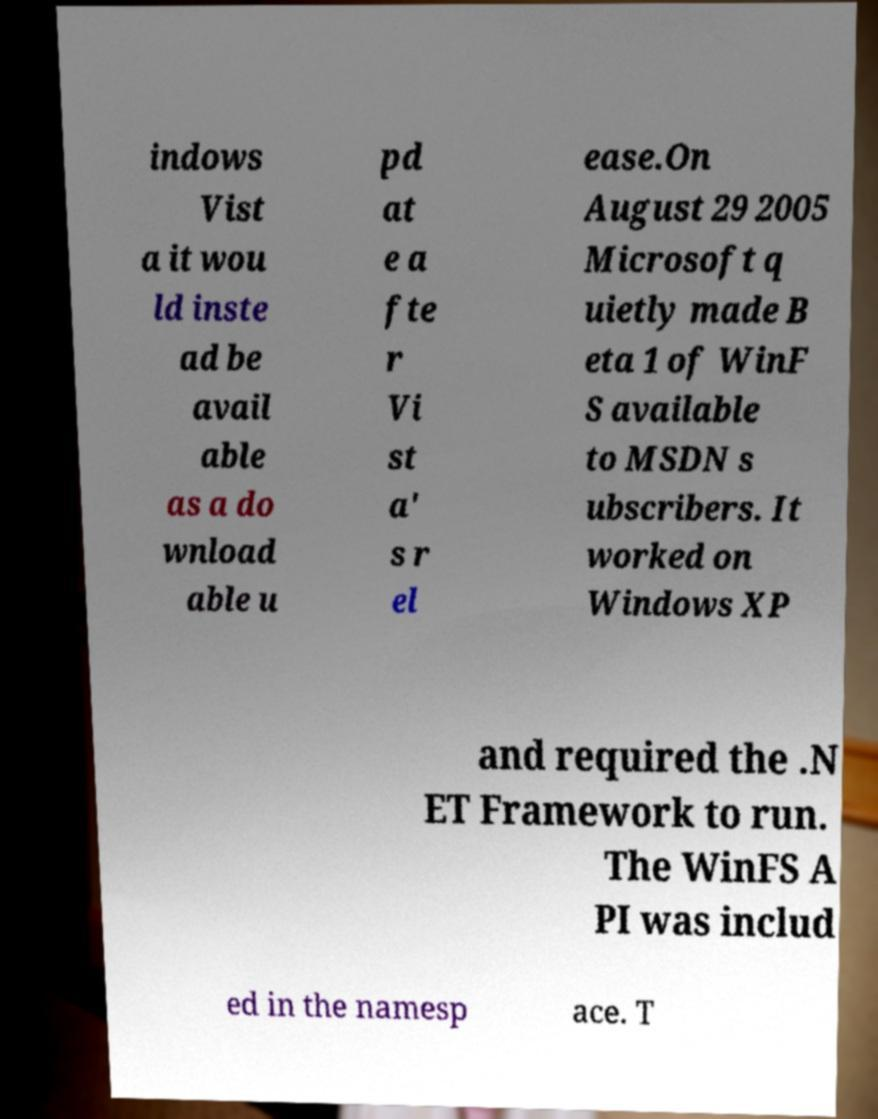Please identify and transcribe the text found in this image. indows Vist a it wou ld inste ad be avail able as a do wnload able u pd at e a fte r Vi st a' s r el ease.On August 29 2005 Microsoft q uietly made B eta 1 of WinF S available to MSDN s ubscribers. It worked on Windows XP and required the .N ET Framework to run. The WinFS A PI was includ ed in the namesp ace. T 